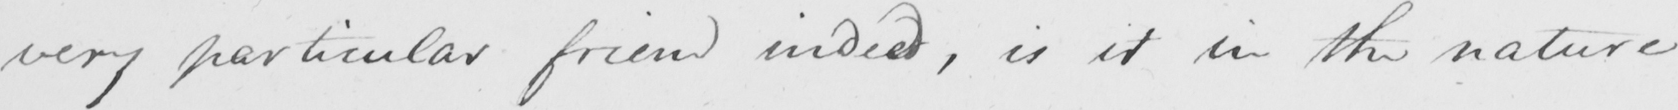Can you read and transcribe this handwriting? very particular friend indeed , is it in the nature 